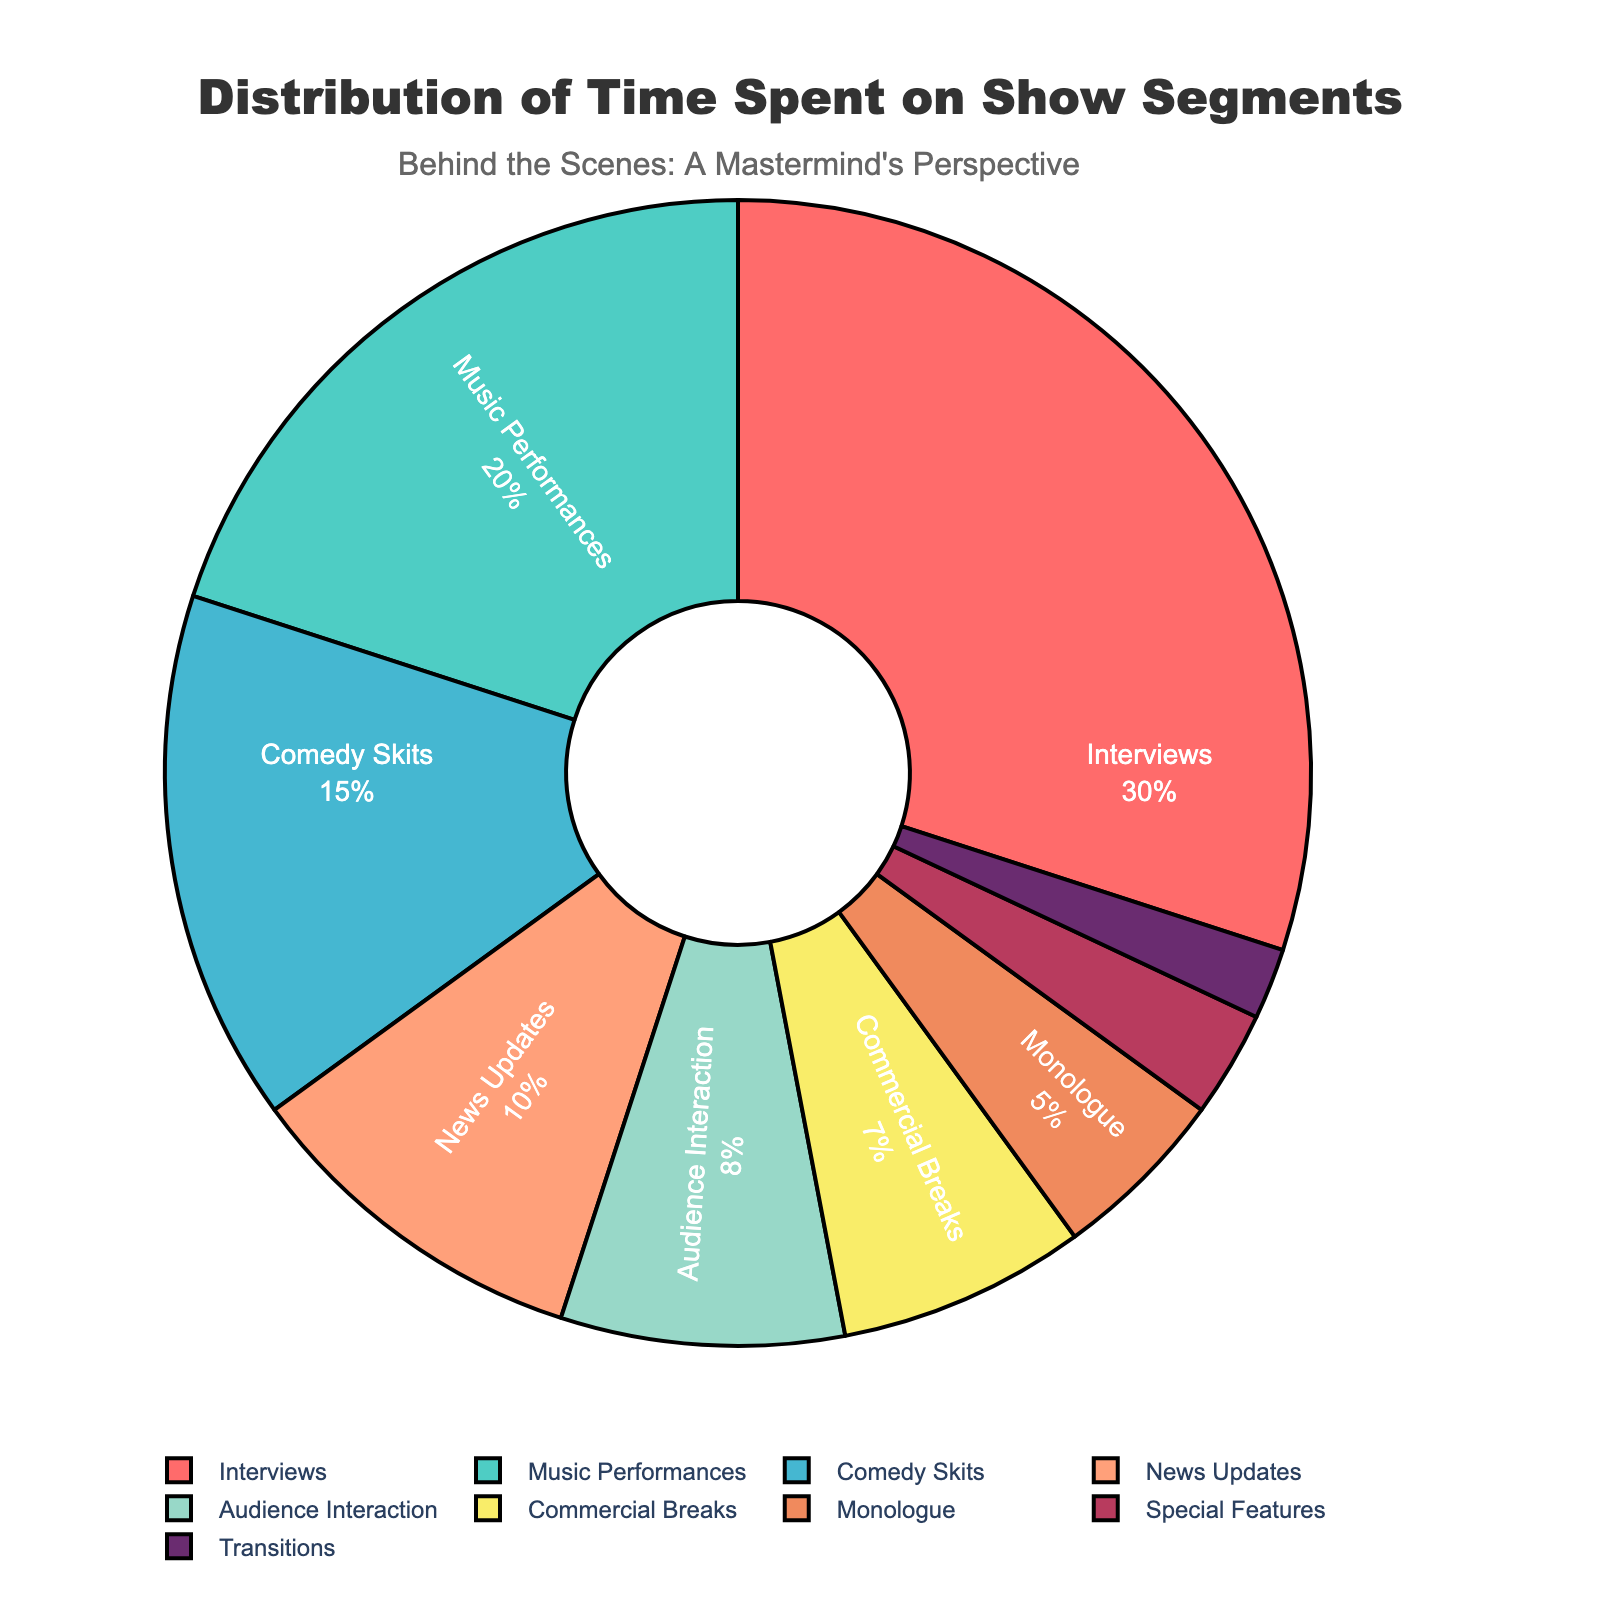What's the largest segment in terms of time spent? The largest segment can be identified by looking at the segment with the highest percentage. In the pie chart, "Interviews" has the largest section.
Answer: Interviews How much time in percentage is spent on "Music Performances"? To find out the time spent on "Music Performances," locate that segment in the pie chart and look at its percentage. The chart shows "Music Performances" as 20%.
Answer: 20% Which segment takes up more time: "News Updates" or "Comedy Skits"? To compare "News Updates" and "Comedy Skits," examine their respective percentages in the pie chart. "Comedy Skits" has 15%, whereas "News Updates" has 10%. Therefore, "Comedy Skits" takes up more time.
Answer: Comedy Skits What is the combined percentage of time spent on "Audience Interaction" and "Commercial Breaks"? To find the combined percentage, add the percentages of "Audience Interaction" and "Commercial Breaks." "Audience Interaction" is 8% and "Commercial Breaks" is 7%, so the total is 8% + 7% = 15%.
Answer: 15% Which segment occupies the smallest portion of the chart? The smallest segment can be determined by identifying the segment with the lowest percentage on the pie chart. "Transitions" has the smallest portion at 2%.
Answer: Transitions What is the difference in percentage between the time spent on "Interviews" and the time spent on "Monologue"? To find the difference, subtract the percentage of "Monologue" from "Interviews." "Interviews" is 30%, and "Monologue" is 5%, so the difference is 30% - 5% = 25%.
Answer: 25% How does the time spent on "Special Features" compare to "Music Performances"? To compare, look at the percentages for both segments in the pie chart. "Special Features" is 3%, and "Music Performances" is 20%. "Music Performances" occupies significantly more time.
Answer: Music Performances occupies more time What's the total percentage of time spent on "Monologue," "Special Features," and "Transitions"? To find the total percentage, add the percentages of "Monologue," "Special Features," and "Transitions." Monologue is 5%, Special Features is 3%, and Transitions is 2%. The total is 5% + 3% + 2% = 10%.
Answer: 10% Which segments occupy more than one-third of the chart combined? To determine which segments collectively occupy more than one-third (33.33%), sum the largest segments until the total surpasses 33.33%. "Interviews" is 30%, and "Music Performances" is 20%. Combined, they total 30% + 20% = 50%. These segments together exceed one-third.
Answer: Interviews and Music Performances 